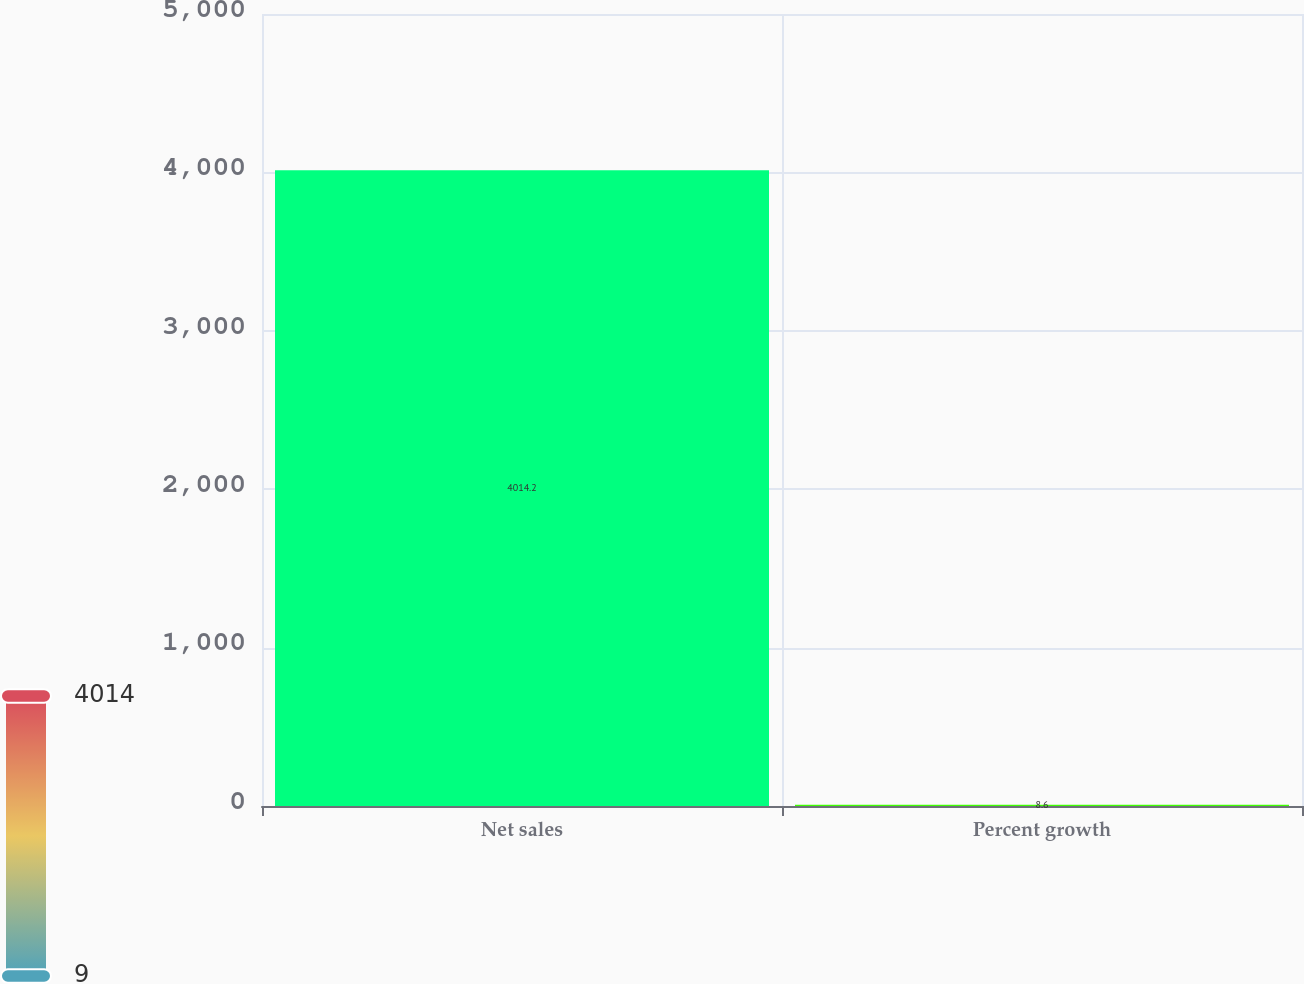Convert chart to OTSL. <chart><loc_0><loc_0><loc_500><loc_500><bar_chart><fcel>Net sales<fcel>Percent growth<nl><fcel>4014.2<fcel>8.6<nl></chart> 